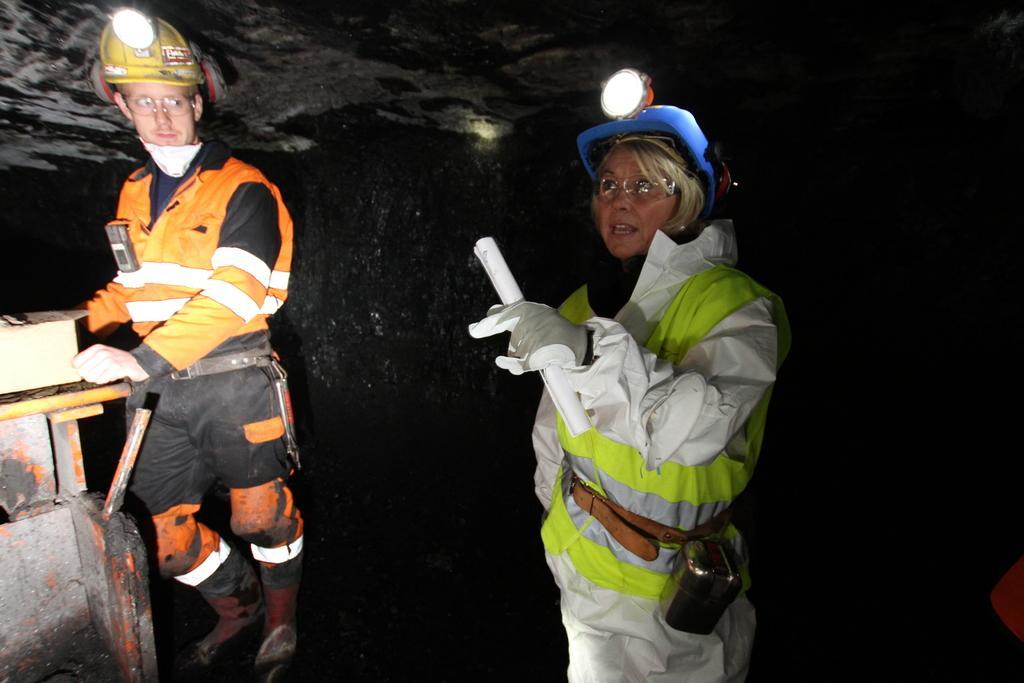Describe this image in one or two sentences. In this image we can see two persons wearing safety helmets and among them a person is holding a paper. Behind the person we can see the wall. At the top we can see the roof. On the left side, we can see an object. 